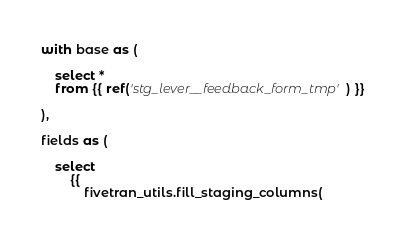<code> <loc_0><loc_0><loc_500><loc_500><_SQL_>
with base as (

    select * 
    from {{ ref('stg_lever__feedback_form_tmp') }}

),

fields as (

    select
        {{
            fivetran_utils.fill_staging_columns(</code> 